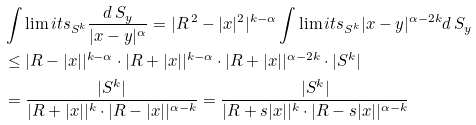Convert formula to latex. <formula><loc_0><loc_0><loc_500><loc_500>& \int \lim i t s _ { S ^ { k } } \frac { d \, S _ { y } } { | x - y | ^ { \alpha } } = | R \, ^ { 2 } - | x | ^ { 2 } | ^ { k - \alpha } \int \lim i t s _ { S ^ { k } } | x - y | ^ { \alpha - 2 k } d \, S _ { y } \\ & \leq | R - | x | | ^ { k - \alpha } \cdot | R + | x | | ^ { k - \alpha } \cdot | R + | x | | ^ { \alpha - 2 k } \cdot | S ^ { k } | \\ & = \frac { | S ^ { k } | } { | R + | x | | ^ { k } \cdot | R - | x | | ^ { \alpha - k } } = \frac { | S ^ { k } | } { | R + s | x | | ^ { k } \cdot | R - s | x | | ^ { \alpha - k } }</formula> 